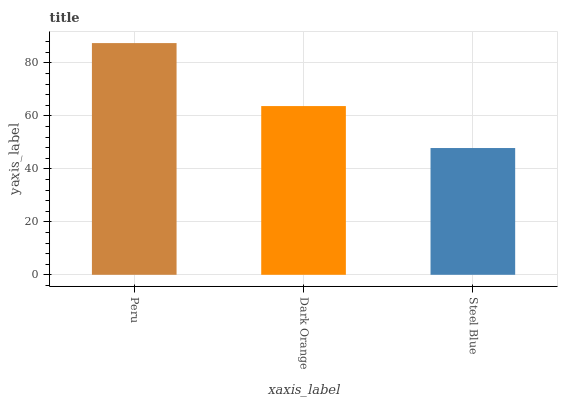Is Steel Blue the minimum?
Answer yes or no. Yes. Is Peru the maximum?
Answer yes or no. Yes. Is Dark Orange the minimum?
Answer yes or no. No. Is Dark Orange the maximum?
Answer yes or no. No. Is Peru greater than Dark Orange?
Answer yes or no. Yes. Is Dark Orange less than Peru?
Answer yes or no. Yes. Is Dark Orange greater than Peru?
Answer yes or no. No. Is Peru less than Dark Orange?
Answer yes or no. No. Is Dark Orange the high median?
Answer yes or no. Yes. Is Dark Orange the low median?
Answer yes or no. Yes. Is Peru the high median?
Answer yes or no. No. Is Peru the low median?
Answer yes or no. No. 